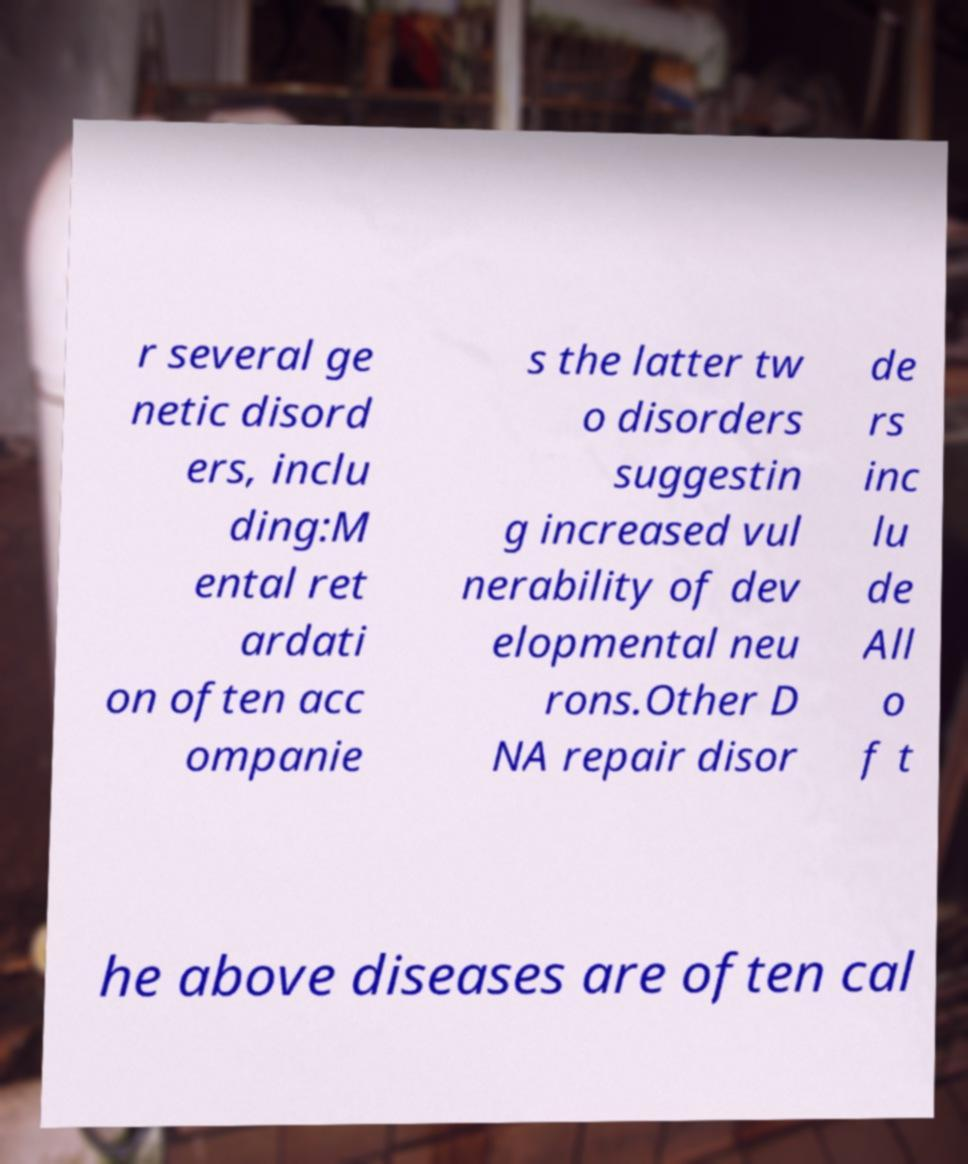Can you accurately transcribe the text from the provided image for me? r several ge netic disord ers, inclu ding:M ental ret ardati on often acc ompanie s the latter tw o disorders suggestin g increased vul nerability of dev elopmental neu rons.Other D NA repair disor de rs inc lu de All o f t he above diseases are often cal 